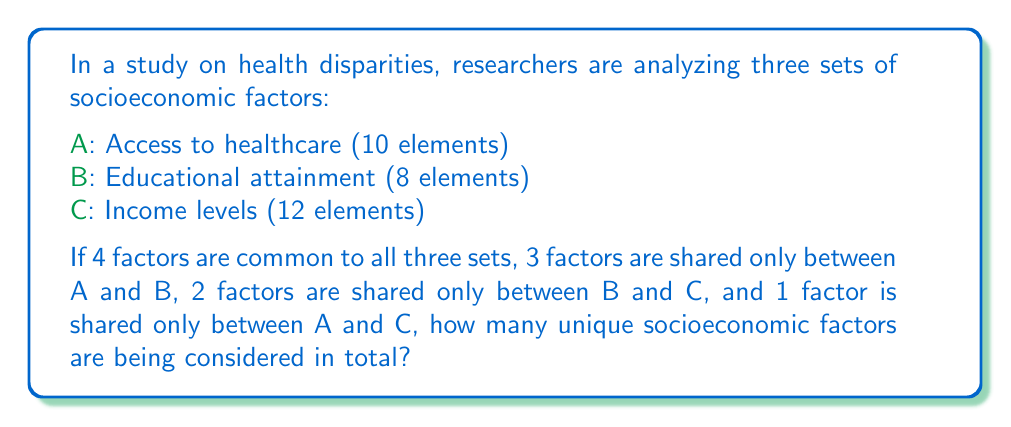Provide a solution to this math problem. To solve this problem, we need to use the principle of inclusion-exclusion for three sets. Let's break it down step-by-step:

1) First, let's define the cardinalities of each set:
   $|A| = 10$, $|B| = 8$, $|C| = 12$

2) We're given the following intersections:
   $|A \cap B \cap C| = 4$
   $|A \cap B| - |A \cap B \cap C| = 3$
   $|B \cap C| - |A \cap B \cap C| = 2$
   $|A \cap C| - |A \cap B \cap C| = 1$

3) The formula for the union of three sets is:
   $$|A \cup B \cup C| = |A| + |B| + |C| - |A \cap B| - |B \cap C| - |A \cap C| + |A \cap B \cap C|$$

4) We can calculate the full intersections:
   $|A \cap B| = 3 + 4 = 7$
   $|B \cap C| = 2 + 4 = 6$
   $|A \cap C| = 1 + 4 = 5$

5) Now, let's substitute these values into our formula:
   $$|A \cup B \cup C| = 10 + 8 + 12 - 7 - 6 - 5 + 4$$

6) Simplifying:
   $$|A \cup B \cup C| = 30 - 18 + 4 = 16$$

Therefore, there are 16 unique socioeconomic factors being considered in total.
Answer: 16 unique socioeconomic factors 